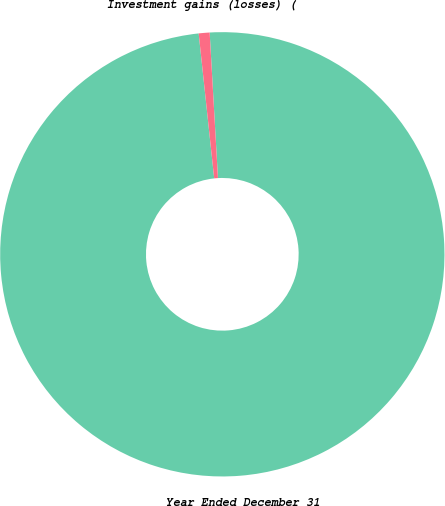Convert chart to OTSL. <chart><loc_0><loc_0><loc_500><loc_500><pie_chart><fcel>Year Ended December 31<fcel>Investment gains (losses) (<nl><fcel>99.21%<fcel>0.79%<nl></chart> 